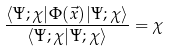Convert formula to latex. <formula><loc_0><loc_0><loc_500><loc_500>\frac { \langle \Psi ; \chi | \Phi ( \vec { x } ) | \Psi ; \chi \rangle } { \langle \Psi ; \chi | \Psi ; \chi \rangle } = \chi</formula> 